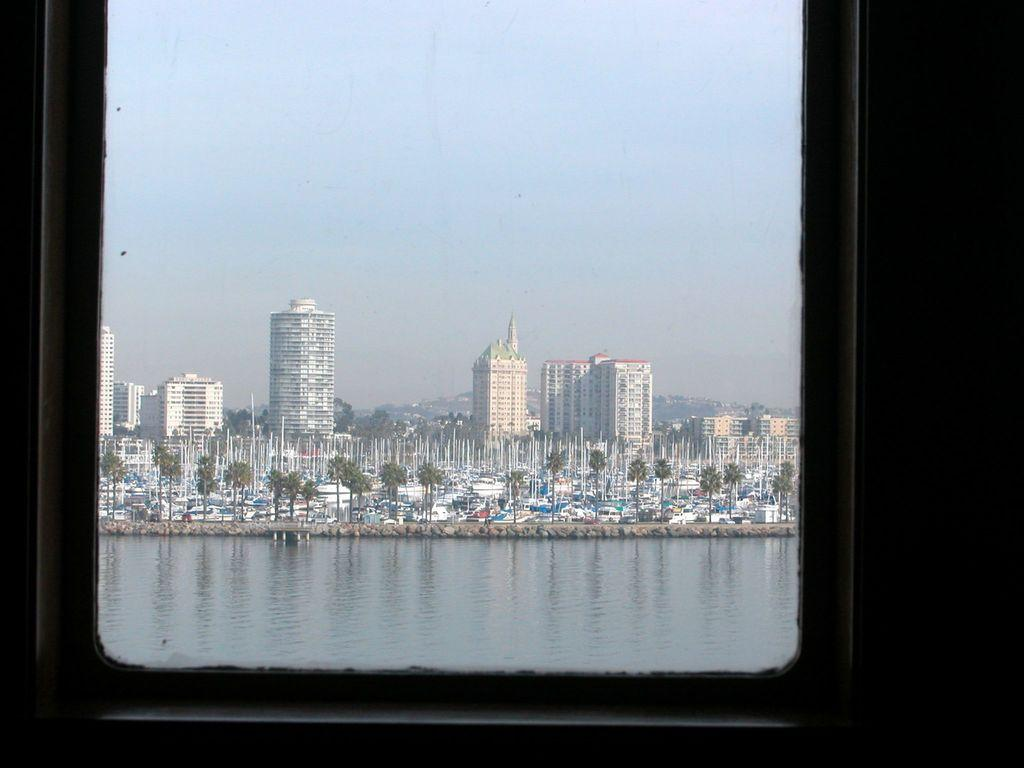What is located in the foreground of the image? There is a window in the foreground of the image. What can be seen through the window? Trees, poles, buildings, vehicles, water, and the sky are visible through the window. Can you describe the view through the window? The view includes a mix of natural elements, such as trees and water, as well as man-made structures like buildings and poles. Vehicles are also visible, suggesting a busy or urban setting. Where are the books located in the image? There are no books visible in the image; the focus is on the view through the window. 